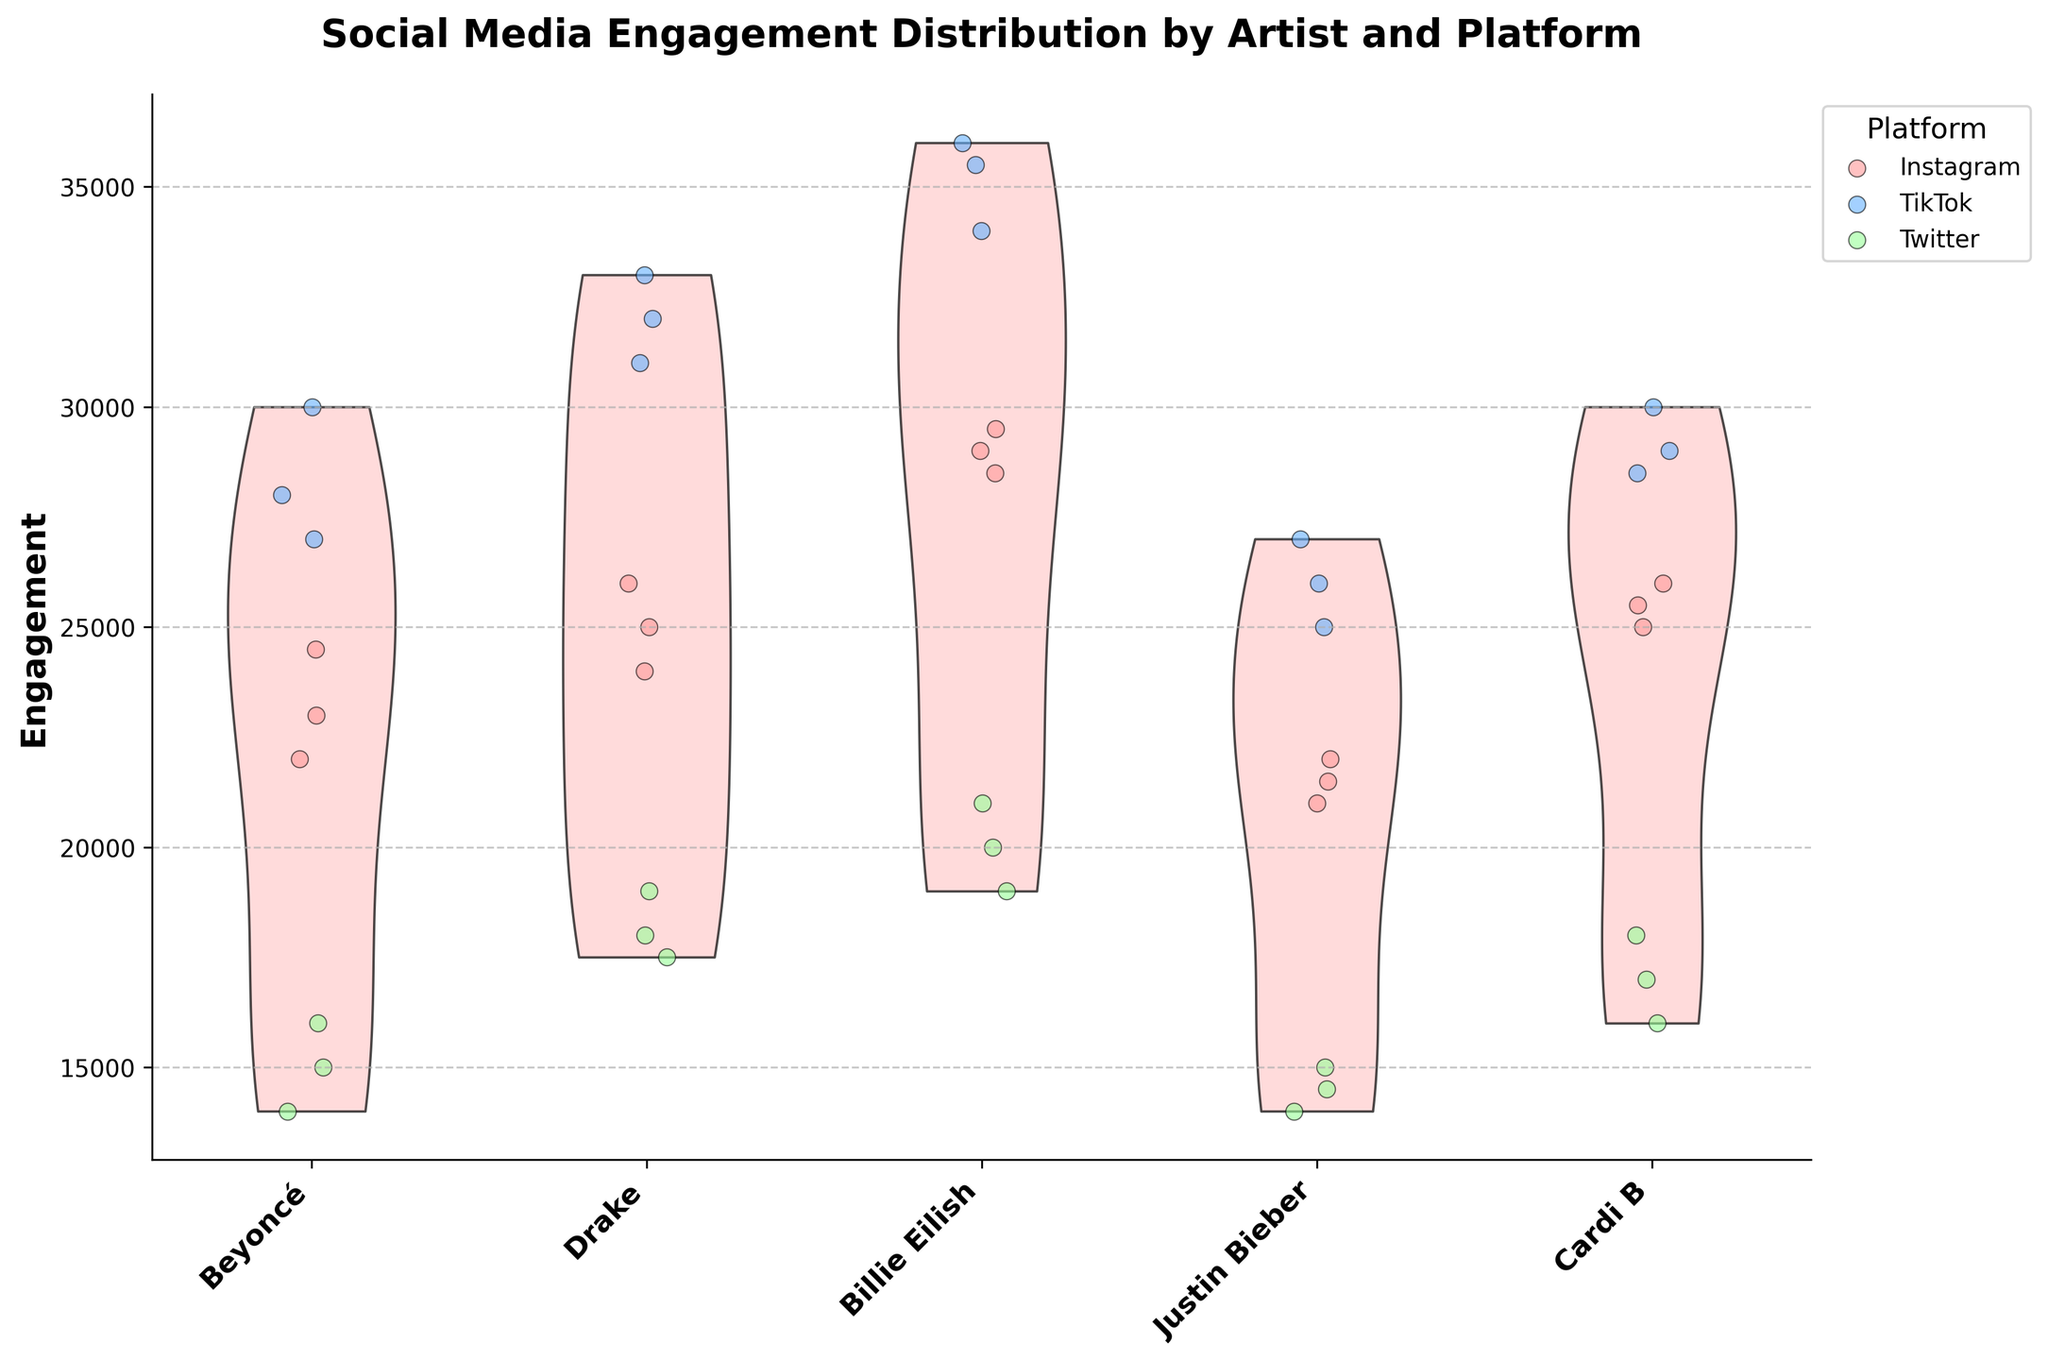What is the title of the figure? The title of the figure is typically located at the top of the chart and summarizes the information presented. In this case, it's "Social Media Engagement Distribution by Artist and Platform."
Answer: Social Media Engagement Distribution by Artist and Platform Which artist shows the highest engagement on TikTok? To find the artist with the highest engagement on TikTok, look for the artist whose jittered points (in one of three colors) on the TikTok section are the highest on the y-axis of the chart. The highest engagement values are from Billie Eilish.
Answer: Billie Eilish How does Cardi B's Twitter engagement compare to her Instagram engagement? To compare Cardi B's engagement on Instagram vs. Twitter, look at the spread of points for both platforms. Cardi B's engagement on Instagram has a higher range (around 25000 to 26000) while her Twitter engagement ranges around 16000 to 18000.
Answer: Lower on Twitter What's the median engagement for Drake on Instagram? To find the median engagement, locate the jittered points for Drake on Instagram, and identify the middle value. The points are 24000, 25000, and 26000, so the median is 25000.
Answer: 25000 Which platform shows the most variation in engagement for Justin Bieber? Variation can be assessed by looking at the spread of points. Justin Bieber shows greater spread on TikTok (ranging from 25000 to 27000) than on other platforms.
Answer: TikTok What color represents Twitter data points in the chart? The legend on the chart indicates which color corresponds to which platform. The color for Twitter data points in the chart is green.
Answer: Green Compare the Instagram engagement ranges for Beyoncé and Billie Eilish. Which one is higher overall? To compare ranges, look at the spread of jittered points for both artists on Instagram. Beyoncé's range (22000 to 24500) is lower overall compared to Billie Eilish's (28500 to 29500).
Answer: Billie Eilish How many engagement points are there in total for Beyoncé on Twitter? Count the orange jittered points corresponding to Beyoncé on Twitter in the figure. There are three jittered points for Beyoncé on Twitter.
Answer: 3 Which platform has the widest spread in engagement values across all artists? To determine the platform with the widest spread, check the scatter of jittered points across platforms. TikTok generally shows the widest spread across all artists.
Answer: TikTok What is the average engagement for Billie Eilish across all platforms? Calculate the average engagement by summing Billie Eilish's engagement values (Instagram: 29000, 29500, 28500; TikTok: 34000, 35500, 36000; Twitter: 20000, 21000, 19000) and dividing by the total number of values. The sum is 242500 and the average is 242500/9 = 26944.44.
Answer: 26944.44 